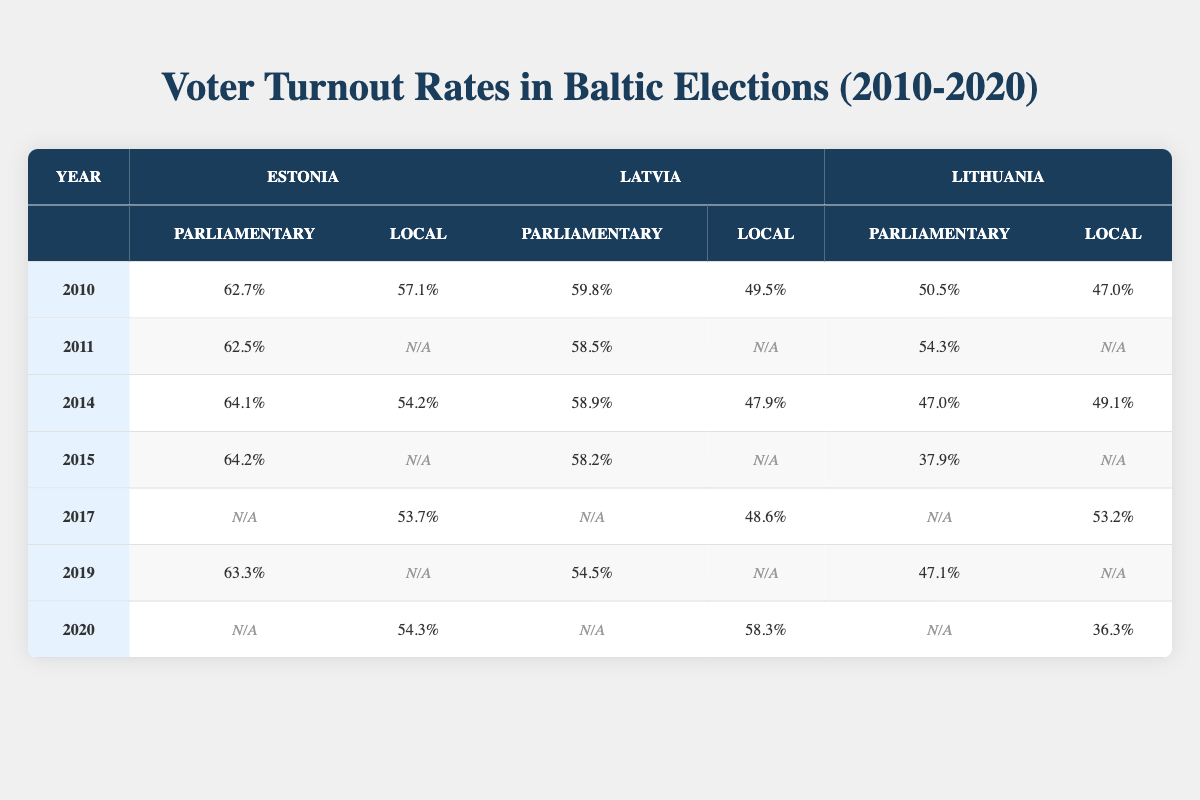What was the voter turnout for Estonia's Parliamentary Election in 2010? According to the table, the voter turnout for Estonia's Parliamentary Election in 2010 is listed as 62.7%.
Answer: 62.7% What was the percentage of voter turnout for Parliamentary Elections in Latvia in 2014? The table shows the voter turnout for Parliamentary Elections in Latvia in 2014 is 58.9%.
Answer: 58.9% Which country had the highest voter turnout in Parliamentary elections in 2015? In 2015, Estonia had the highest voter turnout in Parliamentary elections at 64.2%, compared to Latvia's 58.2% and Lithuania's 37.9%.
Answer: Estonia What is the average voter turnout for local elections in Lithuania from 2010 to 2020? The local elections turnout for Lithuania from 2010 to 2020 is 47.0%, 49.1%, N/A, N/A, 53.2%, N/A, and 36.3%. The average of these values (considering only valid data points) is (47.0 + 49.1 + 53.2 + 36.3) / 4 = 46.4%.
Answer: 46.4% Did Latvia's voter turnout in local elections increase from 2017 to 2020? In 2017, Latvia's local election turnout was 48.6%, and in 2020 it was 58.3%. Since 58.3% is greater than 48.6%, the turnout did increase.
Answer: Yes What was the minimum voter turnout for local elections across the three Baltic states in 2010? By comparing the local election voter turnout across the Baltic states in 2010, Estonia had 57.1%, Latvia had 49.5%, and Lithuania had 47.0%. The minimum is 47.0% from Lithuania.
Answer: 47.0% How did voter turnout for Estonia's Parliamentary Elections change from 2010 to 2019? In 2010, Estonia's parliamentary election turnout was 62.7%, and by 2019, it decreased slightly to 63.3%. This indicates there was a slight increase in turnout over these years.
Answer: Increased What is the difference in voter turnout for local elections between Latvia and Estonia in 2014? In 2014, Latvia's local election turnout was 47.9%, and Estonia's was 54.2%. The difference is 54.2% - 47.9% = 6.3%.
Answer: 6.3% Which year had the highest local election turnout in Estonia? Analyzing the data, Estonia's highest local election turnout was 57.1% in 2010.
Answer: 57.1% Was there a Parliamentary Election in Lithuania in 2020? The table indicates that there is no data provided for Parliamentary Elections in Lithuania for 2020, implying there was no election in that year.
Answer: No What was the pattern of voter turnout for local elections in Lithuania from 2014 to 2020? The data shows local election turnout for Lithuania as follows: 49.1% in 2014, N/A in 2015, N/A in 2017, and 36.3% in 2020. This indicates a steady decrease where the only available data shows turnout falling.
Answer: Decreasing 